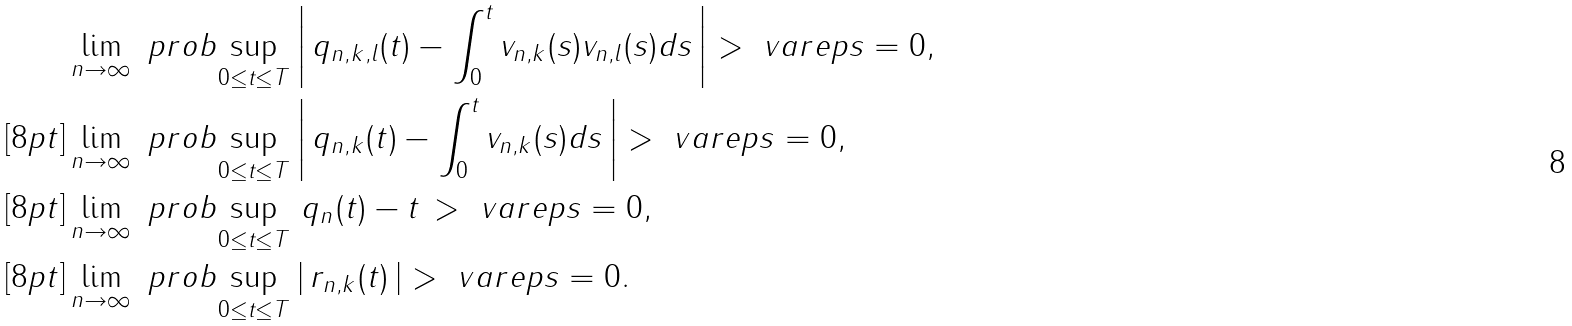<formula> <loc_0><loc_0><loc_500><loc_500>& \lim _ { n \to \infty } \ p r o b { \sup _ { 0 \leq t \leq T } \left | \, q _ { n , k , l } ( t ) - \int _ { 0 } ^ { t } v _ { n , k } ( s ) v _ { n , l } ( s ) d s \, \right | > \ v a r e p s } = 0 , \\ [ 8 p t ] & \lim _ { n \to \infty } \ p r o b { \sup _ { 0 \leq t \leq T } \left | \, q _ { n , k } ( t ) - \int _ { 0 } ^ { t } v _ { n , k } ( s ) d s \, \right | > \ v a r e p s } = 0 , \\ [ 8 p t ] & \lim _ { n \to \infty } \ p r o b { \sup _ { 0 \leq t \leq T } \, q _ { n } ( t ) - t \, > \ v a r e p s } = 0 , \\ [ 8 p t ] & \lim _ { n \to \infty } \ p r o b { \sup _ { 0 \leq t \leq T } \left | \, r _ { n , k } ( t ) \, \right | > \ v a r e p s } = 0 .</formula> 